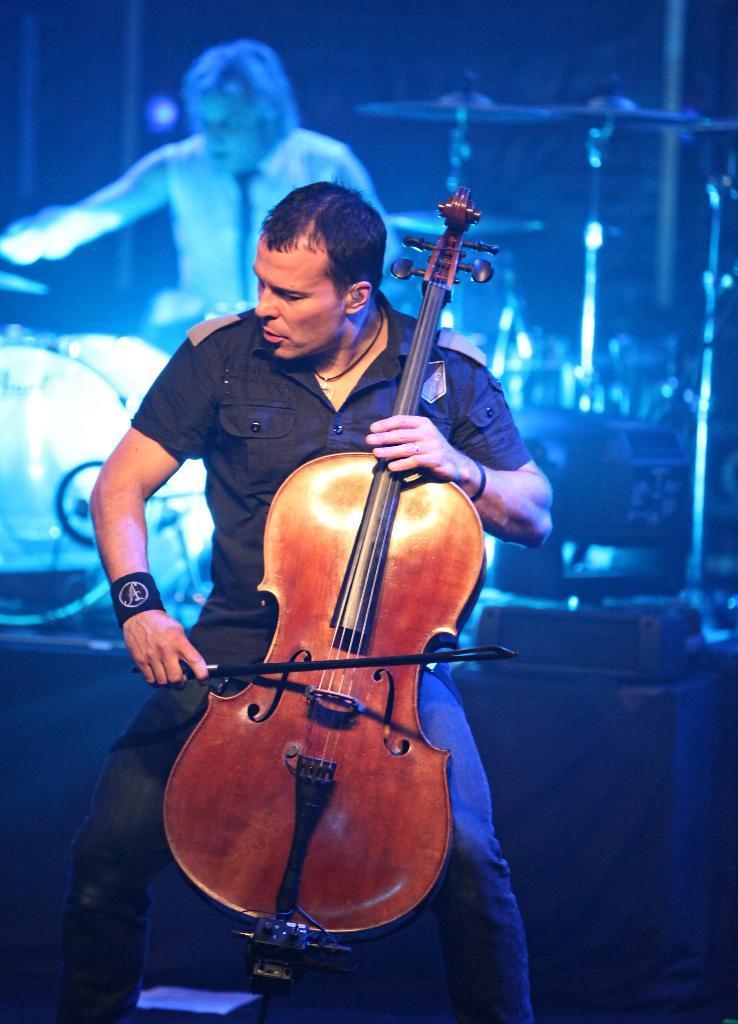How would you summarize this image in a sentence or two? In this image we can see a person sitting on the chair and holding a musical instrument in his hands. In the background there are musical instruments and a person sitting on the chair. 